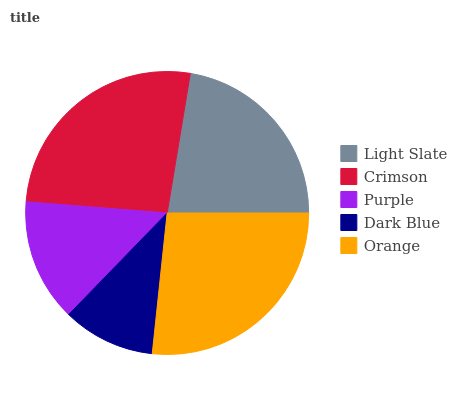Is Dark Blue the minimum?
Answer yes or no. Yes. Is Orange the maximum?
Answer yes or no. Yes. Is Crimson the minimum?
Answer yes or no. No. Is Crimson the maximum?
Answer yes or no. No. Is Crimson greater than Light Slate?
Answer yes or no. Yes. Is Light Slate less than Crimson?
Answer yes or no. Yes. Is Light Slate greater than Crimson?
Answer yes or no. No. Is Crimson less than Light Slate?
Answer yes or no. No. Is Light Slate the high median?
Answer yes or no. Yes. Is Light Slate the low median?
Answer yes or no. Yes. Is Crimson the high median?
Answer yes or no. No. Is Crimson the low median?
Answer yes or no. No. 